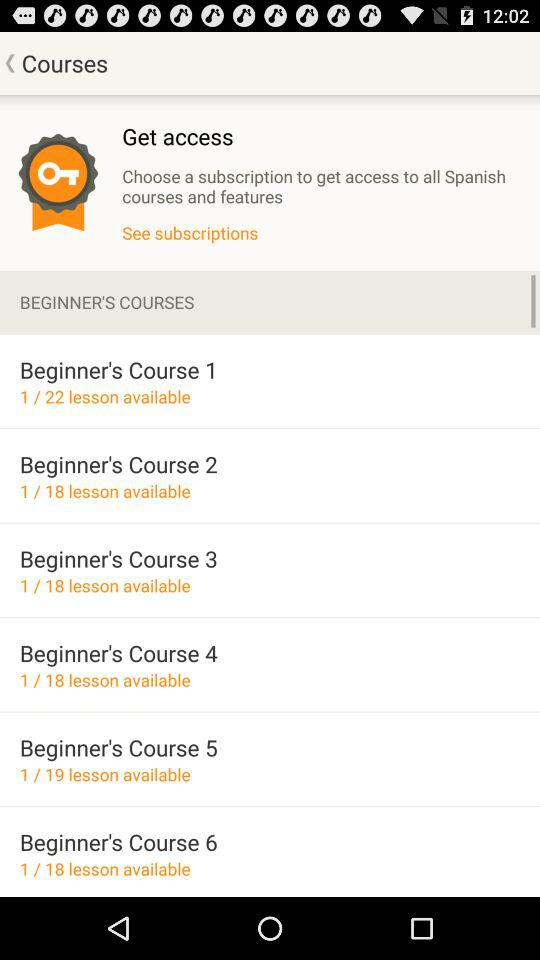What is the number of lessons available in "Beginner's Course 3"? The number of lessons is 18. 